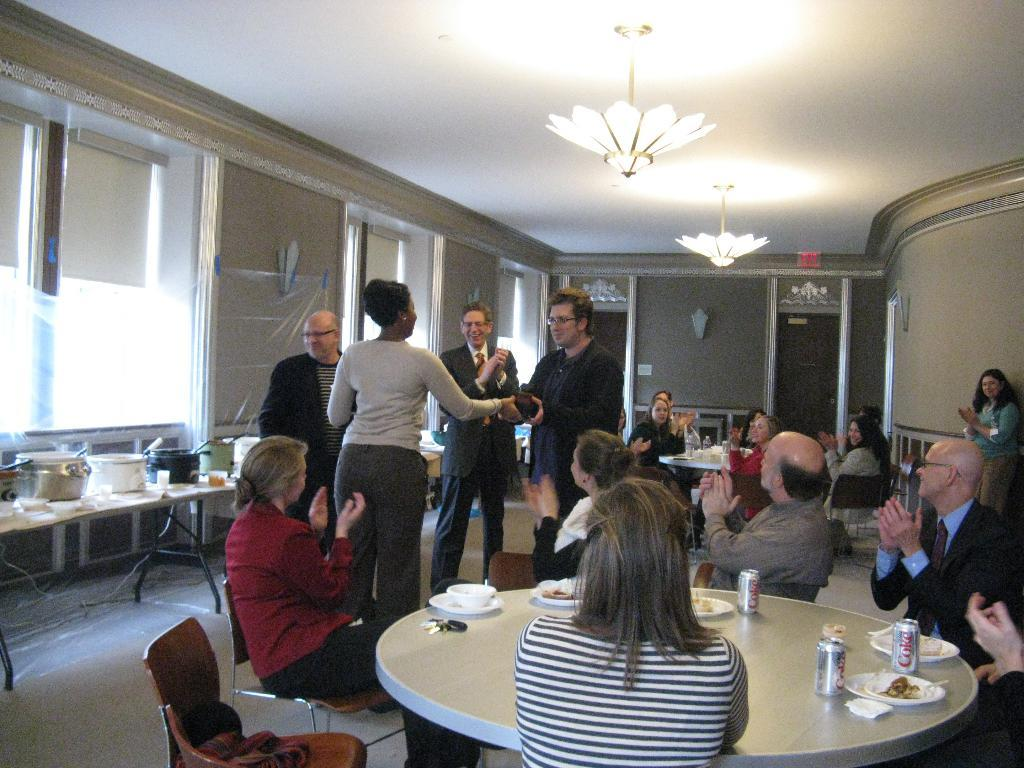What can be seen in the image that provides illumination? There are lights in the image. What type of structure is present in the background of the image? There is a wall in the image. What piece of furniture is visible in the image? There is a table in the image. What objects are on the table? There are bowls on the table. What are the people in the image doing? There are people sitting and standing in the image. What type of business is being conducted in the image? There is no indication of a business being conducted in the image. What songs are being sung by the people in the image? There is no indication of anyone singing in the image. 